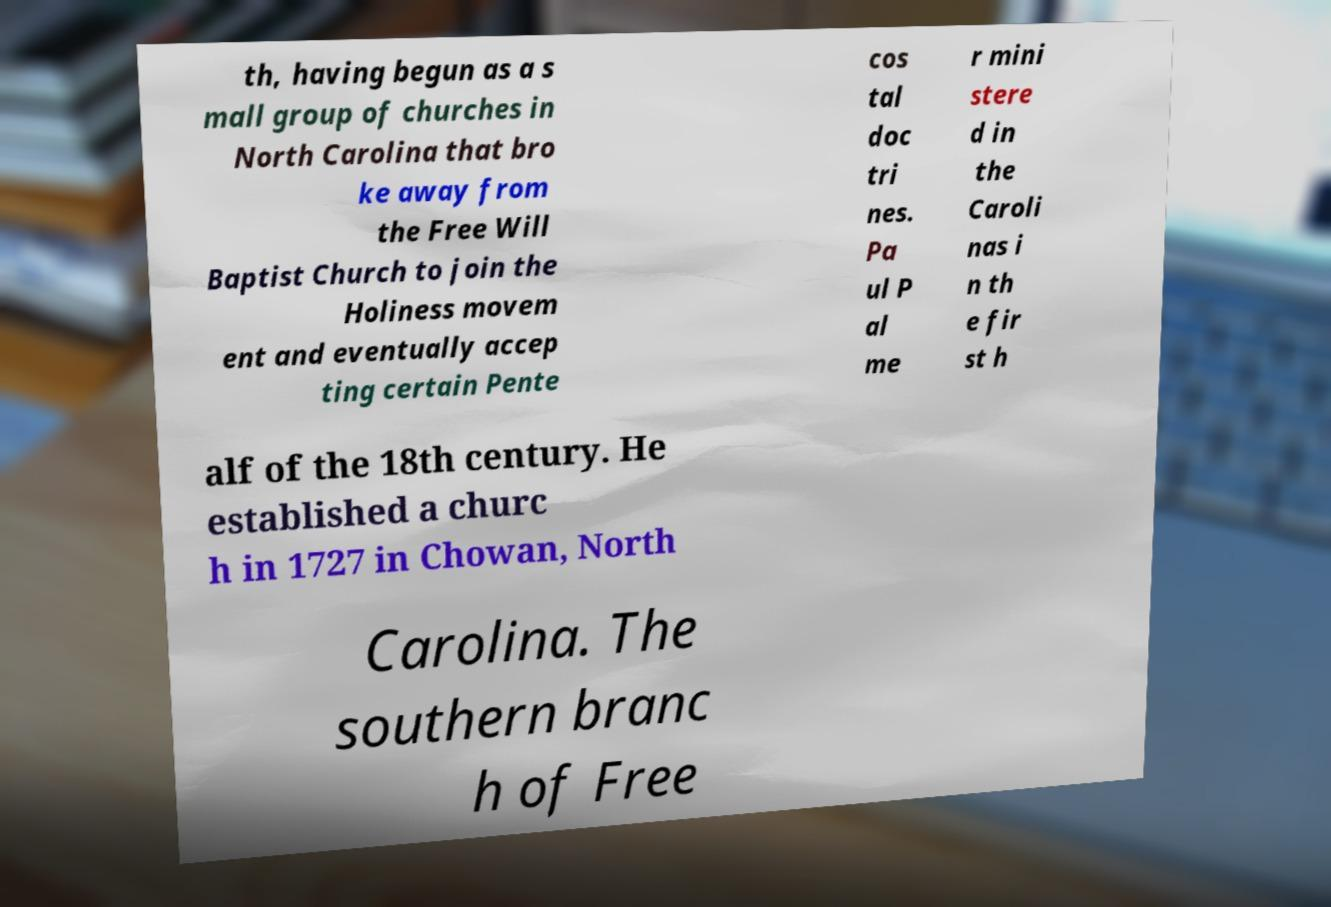Can you accurately transcribe the text from the provided image for me? th, having begun as a s mall group of churches in North Carolina that bro ke away from the Free Will Baptist Church to join the Holiness movem ent and eventually accep ting certain Pente cos tal doc tri nes. Pa ul P al me r mini stere d in the Caroli nas i n th e fir st h alf of the 18th century. He established a churc h in 1727 in Chowan, North Carolina. The southern branc h of Free 